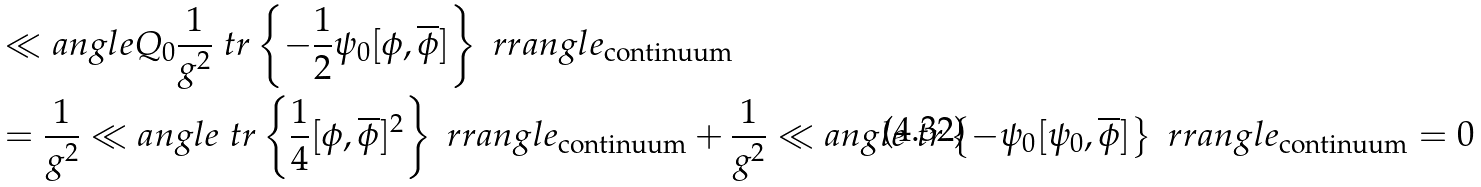<formula> <loc_0><loc_0><loc_500><loc_500>& \ll a n g l e Q _ { 0 } \frac { 1 } { g ^ { 2 } } \ t r \left \{ - \frac { 1 } { 2 } \psi _ { 0 } [ \phi , \overline { \phi } ] \right \} \ r r a n g l e _ { \text {continuum} } \\ & = \frac { 1 } { g ^ { 2 } } \ll a n g l e \ t r \left \{ \frac { 1 } { 4 } [ \phi , \overline { \phi } ] ^ { 2 } \right \} \ r r a n g l e _ { \text {continuum} } + \frac { 1 } { g ^ { 2 } } \ll a n g l e \ t r \left \{ - \psi _ { 0 } [ \psi _ { 0 } , \overline { \phi } ] \right \} \ r r a n g l e _ { \text {continuum} } = 0</formula> 